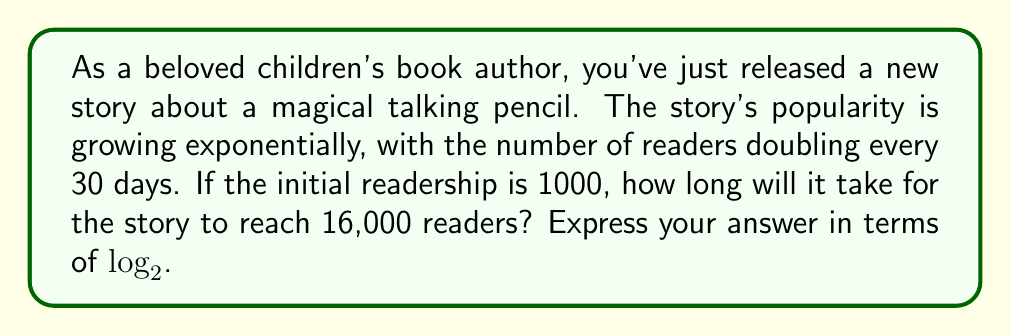Can you solve this math problem? Let's approach this step-by-step:

1) Let $t$ be the time in days and $P(t)$ be the number of readers at time $t$.

2) The initial number of readers is 1000, so $P(0) = 1000$.

3) We're told the number of readers doubles every 30 days. This gives us the exponential growth formula:

   $P(t) = 1000 \cdot 2^{\frac{t}{30}}$

4) We want to find $t$ when $P(t) = 16000$. So, let's set up the equation:

   $16000 = 1000 \cdot 2^{\frac{t}{30}}$

5) Divide both sides by 1000:

   $16 = 2^{\frac{t}{30}}$

6) Now, we can apply $\log_2$ to both sides:

   $\log_2 16 = \log_2 (2^{\frac{t}{30}})$

7) The right side simplifies due to the logarithm rule $\log_a (a^x) = x$:

   $\log_2 16 = \frac{t}{30}$

8) We know that $\log_2 16 = 4$ (since $2^4 = 16$), so:

   $4 = \frac{t}{30}$

9) Multiply both sides by 30:

   $t = 4 \cdot 30 = 120$

Therefore, it will take 120 days for the readership to reach 16,000.

To express this in terms of $\log_2$ as requested, we can rewrite the final step as:

$t = 30 \cdot \log_2 16$
Answer: $30 \cdot \log_2 16$ days 